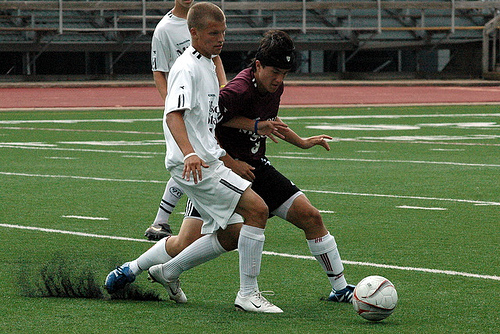<image>
Is there a ball behind the man? No. The ball is not behind the man. From this viewpoint, the ball appears to be positioned elsewhere in the scene. 